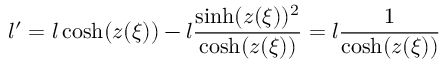<formula> <loc_0><loc_0><loc_500><loc_500>l ^ { \prime } = l \cosh ( z ( \xi ) ) - l \frac { \sinh ( z ( \xi ) ) ^ { 2 } } { \cosh ( z ( \xi ) ) } = l \frac { 1 } { \cosh ( z ( \xi ) ) }</formula> 